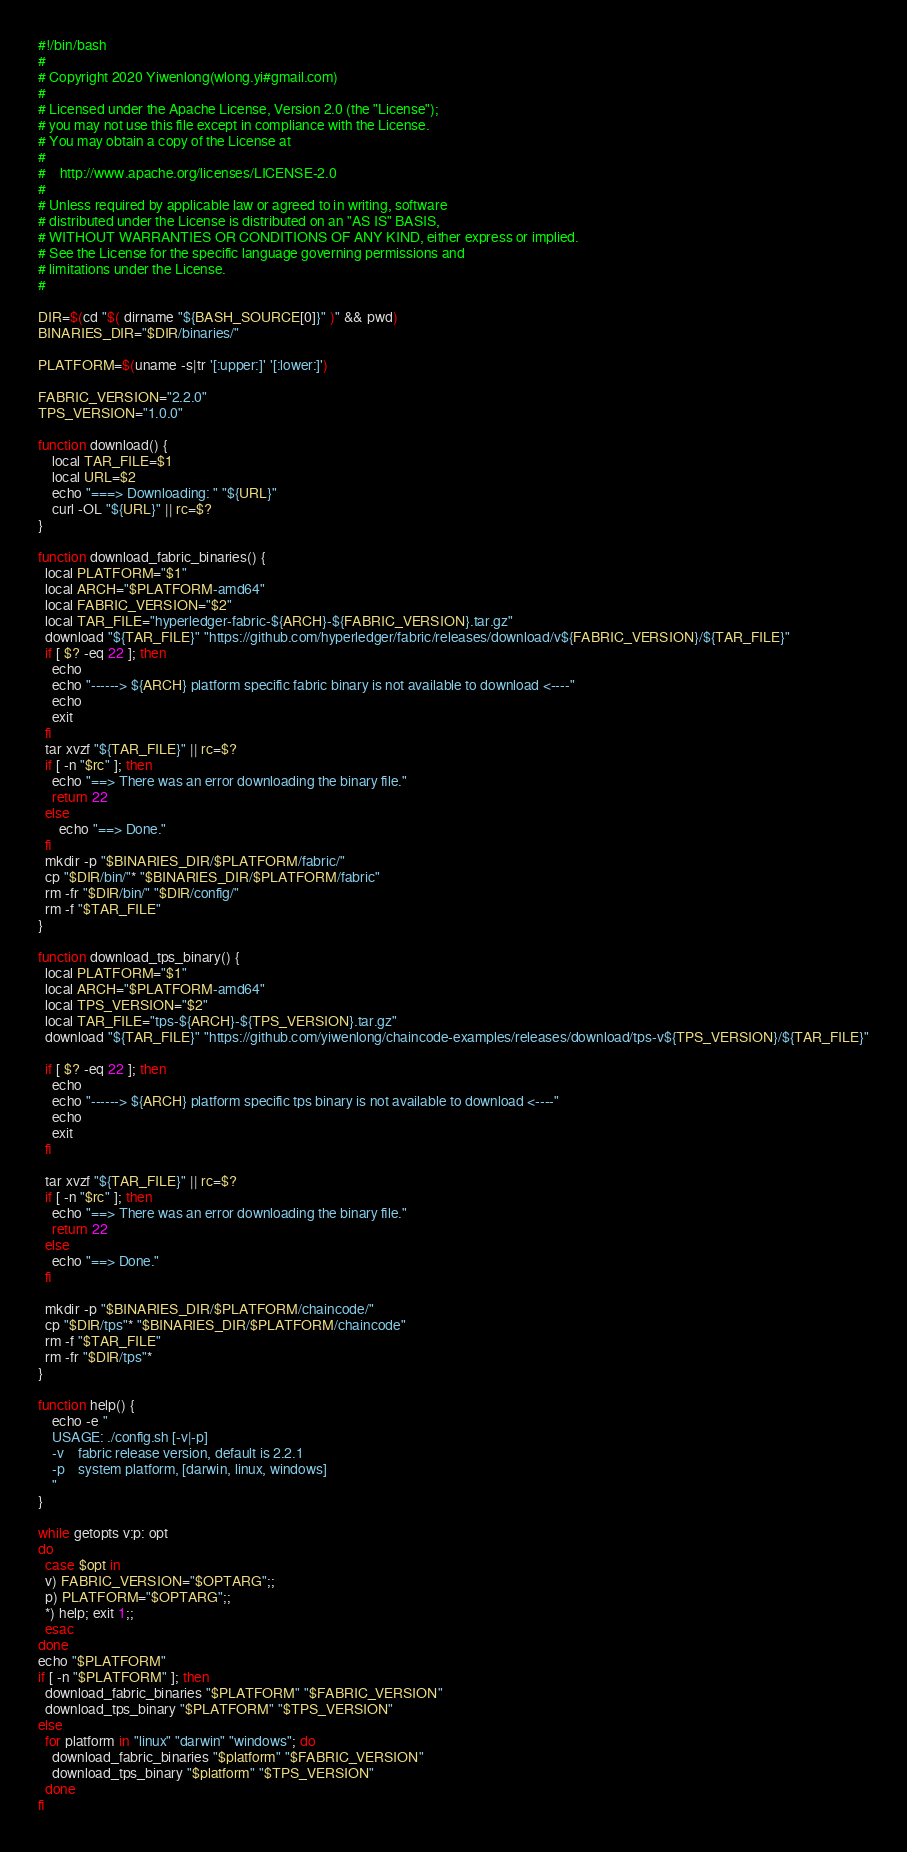Convert code to text. <code><loc_0><loc_0><loc_500><loc_500><_Bash_>#!/bin/bash
#
# Copyright 2020 Yiwenlong(wlong.yi#gmail.com)
#
# Licensed under the Apache License, Version 2.0 (the "License");
# you may not use this file except in compliance with the License.
# You may obtain a copy of the License at
#
#    http://www.apache.org/licenses/LICENSE-2.0
#
# Unless required by applicable law or agreed to in writing, software
# distributed under the License is distributed on an "AS IS" BASIS,
# WITHOUT WARRANTIES OR CONDITIONS OF ANY KIND, either express or implied.
# See the License for the specific language governing permissions and
# limitations under the License.
#

DIR=$(cd "$( dirname "${BASH_SOURCE[0]}" )" && pwd)
BINARIES_DIR="$DIR/binaries/"

PLATFORM=$(uname -s|tr '[:upper:]' '[:lower:]')

FABRIC_VERSION="2.2.0"
TPS_VERSION="1.0.0"

function download() {
    local TAR_FILE=$1
    local URL=$2
    echo "===> Downloading: " "${URL}"
    curl -OL "${URL}" || rc=$?
}

function download_fabric_binaries() {
  local PLATFORM="$1"
  local ARCH="$PLATFORM-amd64"
  local FABRIC_VERSION="$2"
  local TAR_FILE="hyperledger-fabric-${ARCH}-${FABRIC_VERSION}.tar.gz"
  download "${TAR_FILE}" "https://github.com/hyperledger/fabric/releases/download/v${FABRIC_VERSION}/${TAR_FILE}"
  if [ $? -eq 22 ]; then
    echo
    echo "------> ${ARCH} platform specific fabric binary is not available to download <----"
    echo
    exit
  fi
  tar xvzf "${TAR_FILE}" || rc=$?
  if [ -n "$rc" ]; then
    echo "==> There was an error downloading the binary file."
    return 22
  else
      echo "==> Done."
  fi
  mkdir -p "$BINARIES_DIR/$PLATFORM/fabric/"
  cp "$DIR/bin/"* "$BINARIES_DIR/$PLATFORM/fabric"
  rm -fr "$DIR/bin/" "$DIR/config/"
  rm -f "$TAR_FILE"
}

function download_tps_binary() {
  local PLATFORM="$1"
  local ARCH="$PLATFORM-amd64"
  local TPS_VERSION="$2"
  local TAR_FILE="tps-${ARCH}-${TPS_VERSION}.tar.gz"
  download "${TAR_FILE}" "https://github.com/yiwenlong/chaincode-examples/releases/download/tps-v${TPS_VERSION}/${TAR_FILE}"

  if [ $? -eq 22 ]; then
    echo
    echo "------> ${ARCH} platform specific tps binary is not available to download <----"
    echo
    exit
  fi

  tar xvzf "${TAR_FILE}" || rc=$?
  if [ -n "$rc" ]; then
    echo "==> There was an error downloading the binary file."
    return 22
  else
    echo "==> Done."
  fi

  mkdir -p "$BINARIES_DIR/$PLATFORM/chaincode/"
  cp "$DIR/tps"* "$BINARIES_DIR/$PLATFORM/chaincode"
  rm -f "$TAR_FILE"
  rm -fr "$DIR/tps"*
}

function help() {
    echo -e "
    USAGE: ./config.sh [-v|-p]
    -v    fabric release version, default is 2.2.1
    -p    system platform, [darwin, linux, windows]
    "
}

while getopts v:p: opt
do
  case $opt in
  v) FABRIC_VERSION="$OPTARG";;
  p) PLATFORM="$OPTARG";;
  *) help; exit 1;;
  esac
done
echo "$PLATFORM"
if [ -n "$PLATFORM" ]; then
  download_fabric_binaries "$PLATFORM" "$FABRIC_VERSION"
  download_tps_binary "$PLATFORM" "$TPS_VERSION"
else
  for platform in "linux" "darwin" "windows"; do
    download_fabric_binaries "$platform" "$FABRIC_VERSION"
    download_tps_binary "$platform" "$TPS_VERSION"
  done
fi</code> 